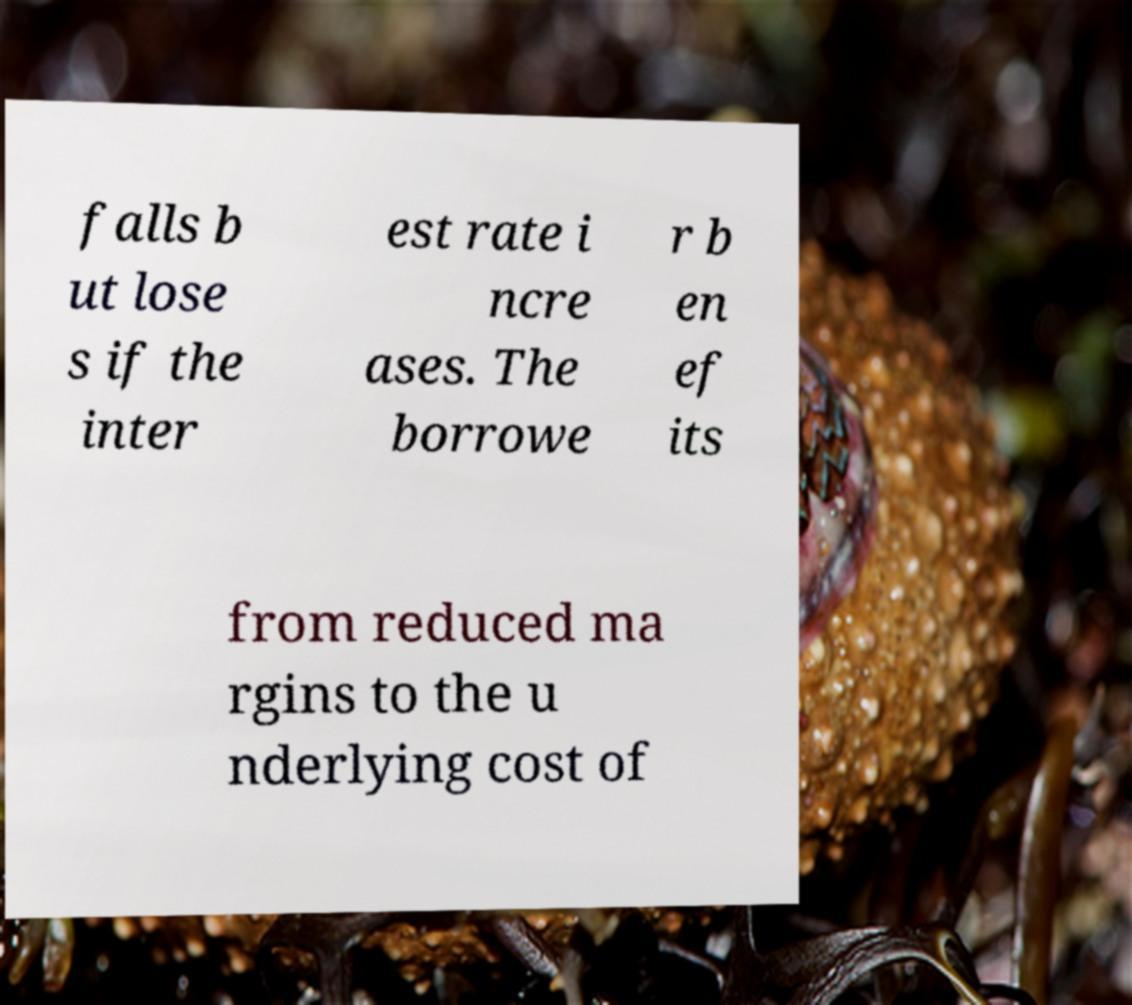Could you extract and type out the text from this image? falls b ut lose s if the inter est rate i ncre ases. The borrowe r b en ef its from reduced ma rgins to the u nderlying cost of 